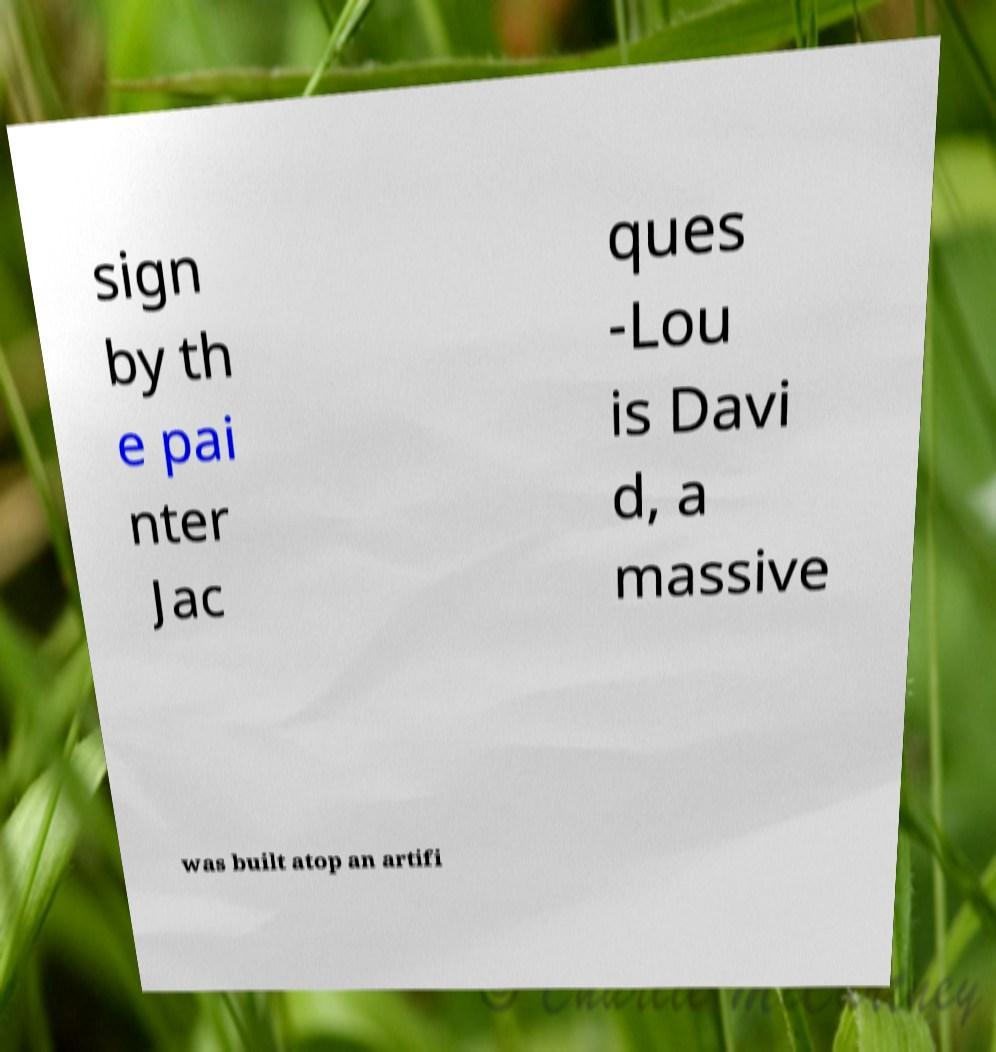Please read and relay the text visible in this image. What does it say? sign by th e pai nter Jac ques -Lou is Davi d, a massive was built atop an artifi 